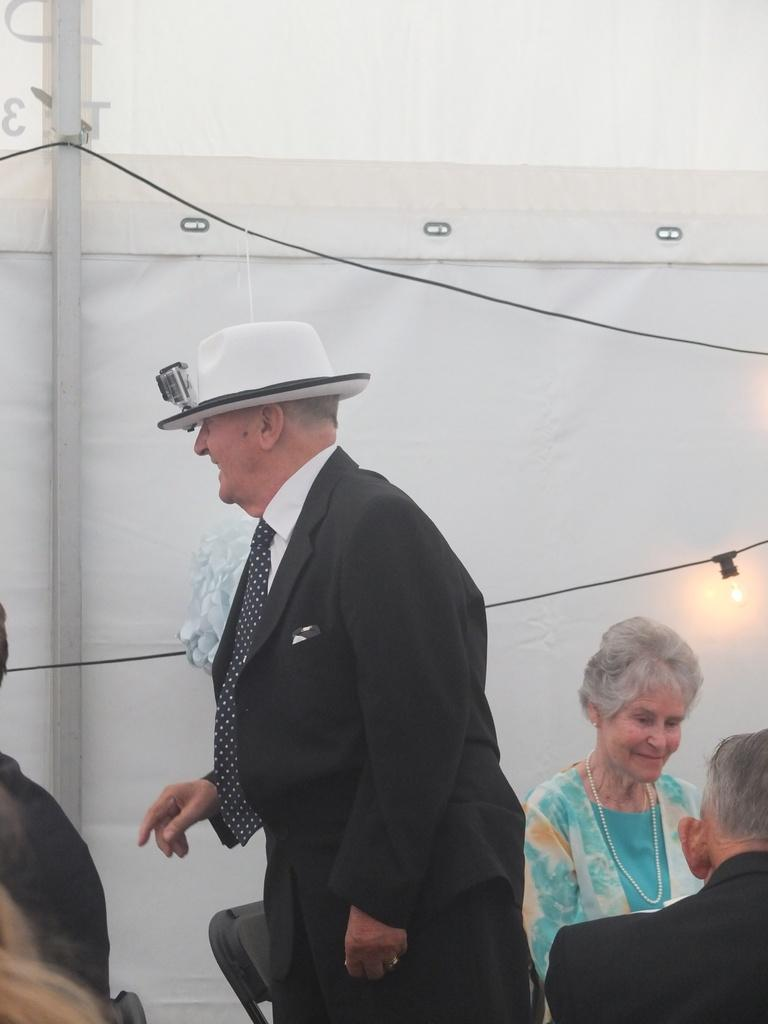Who or what is present in the image? There are people in the image. What can be seen in the image that provides illumination? There is light visible in the image. What type of background element is present in the image? There is a white curtain in the background of the image. What type of winter drink is being served in the image? There is no drink present in the image, and the facts provided do not mention any season, so it cannot be determined if a winter drink is being served. 